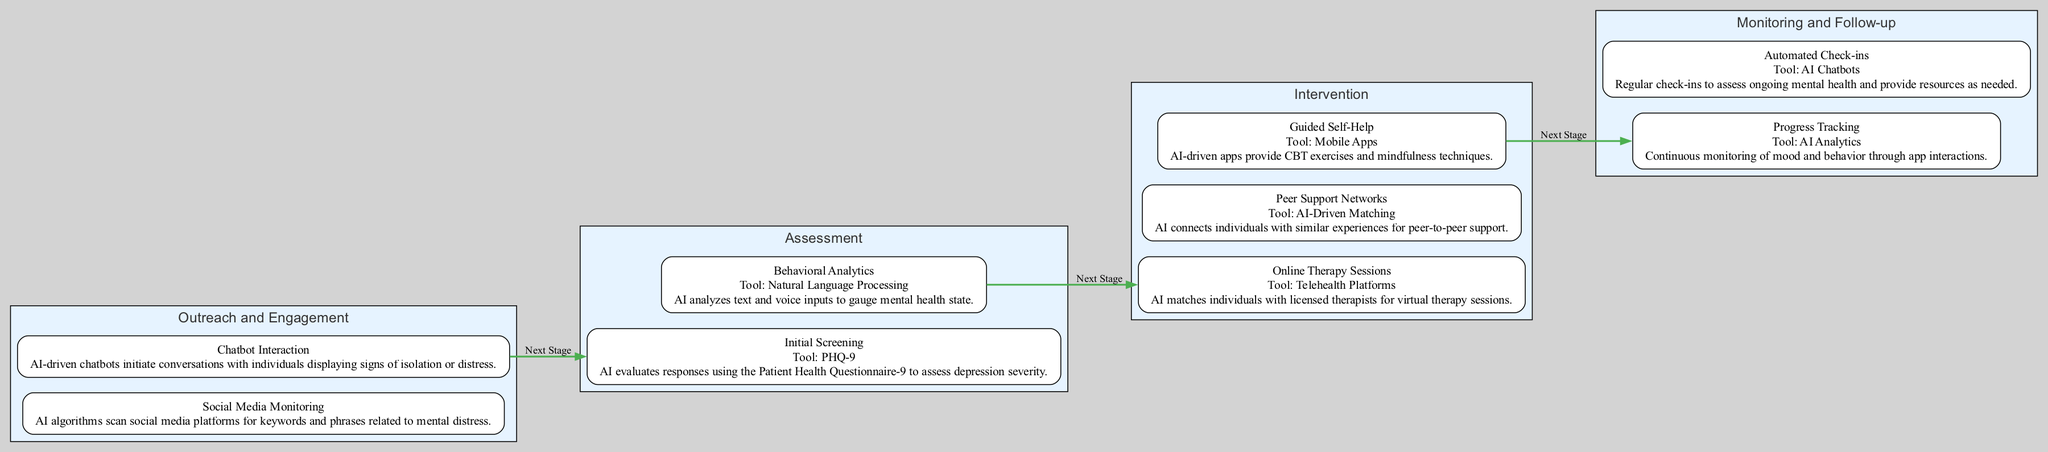What is the first stage in the pathway? The diagram presents the stages in order, with the first stage labeled as "Outreach and Engagement."
Answer: Outreach and Engagement How many interventions are listed in the Assessment stage? By counting the components outlined under the Assessment stage, there are two interventions mentioned: "Initial Screening" and "Behavioral Analytics."
Answer: 2 What tool is used for initial screening in the Assessment stage? The diagram specifies "PHQ-9" as the tool used for the initial screening intervention in the Assessment stage.
Answer: PHQ-9 Which intervention connects individuals with similar experiences? The intervention titled "Peer Support Networks" is specifically designed to connect individuals with similar experiences, as noted in the Intervention stage.
Answer: Peer Support Networks What is the last intervention in the Monitoring and Follow-up stage? The last intervention mentioned in the Monitoring and Follow-up stage is "Automated Check-ins," which is listed as the final component.
Answer: Automated Check-ins What tool supports online therapy sessions in the Intervention stage? The tool indicated for online therapy sessions is "Telehealth Platforms," as described under the Intervention stage.
Answer: Telehealth Platforms Which stage follows the Assessment stage? The diagram indicates that the stage following Assessment is the "Intervention" stage, as shown with a directed edge from Assessment to Intervention.
Answer: Intervention How is the mental health state assessed in the Assessment stage? The mental health state is assessed through "Behavioral Analytics" which uses Natural Language Processing, as the description explains in the intervention details.
Answer: Behavioral Analytics What type of support is provided through guided self-help? The diagram refers to "CBT exercises and mindfulness techniques" as the type of support provided through the Guided Self-Help intervention, as indicated in its description.
Answer: CBT exercises and mindfulness techniques 